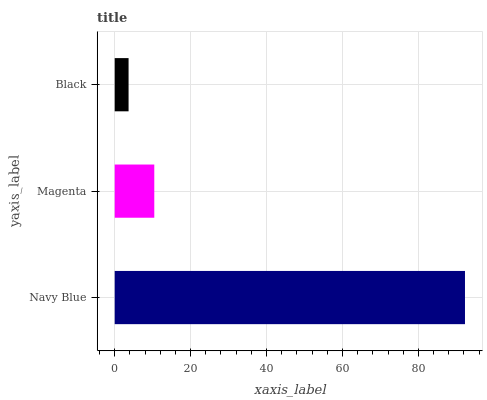Is Black the minimum?
Answer yes or no. Yes. Is Navy Blue the maximum?
Answer yes or no. Yes. Is Magenta the minimum?
Answer yes or no. No. Is Magenta the maximum?
Answer yes or no. No. Is Navy Blue greater than Magenta?
Answer yes or no. Yes. Is Magenta less than Navy Blue?
Answer yes or no. Yes. Is Magenta greater than Navy Blue?
Answer yes or no. No. Is Navy Blue less than Magenta?
Answer yes or no. No. Is Magenta the high median?
Answer yes or no. Yes. Is Magenta the low median?
Answer yes or no. Yes. Is Navy Blue the high median?
Answer yes or no. No. Is Black the low median?
Answer yes or no. No. 